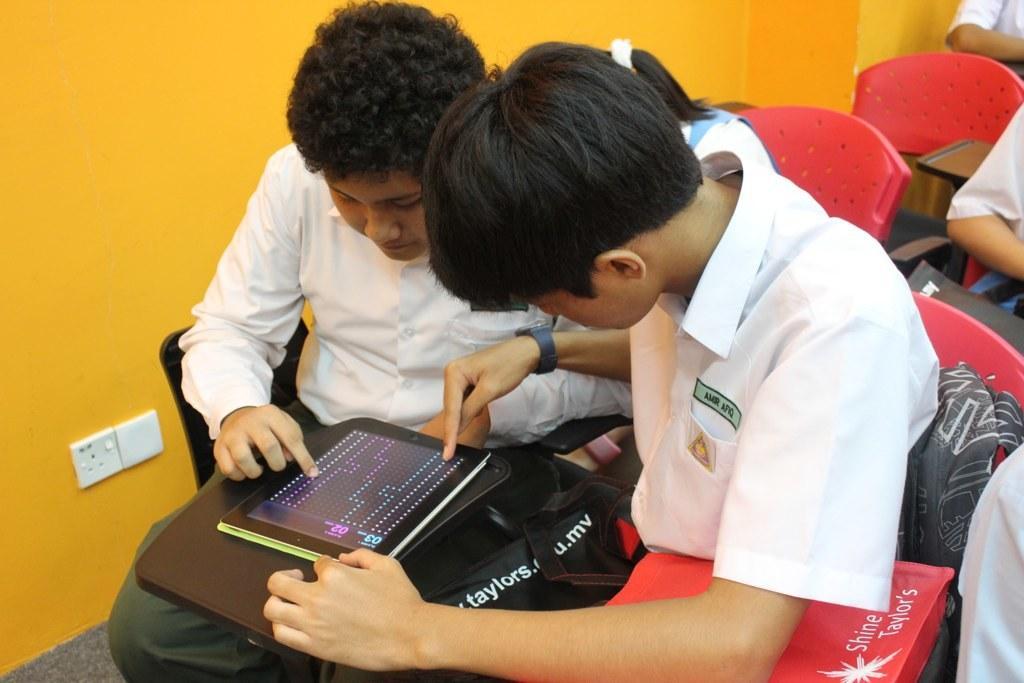Please provide a concise description of this image. This picture might be taken in a room. In the center of the picture there are two persons seated and playing in a mobile, they are wearing white shirts. On the left there is a yellow color wall. In the picture there are red chairs. 